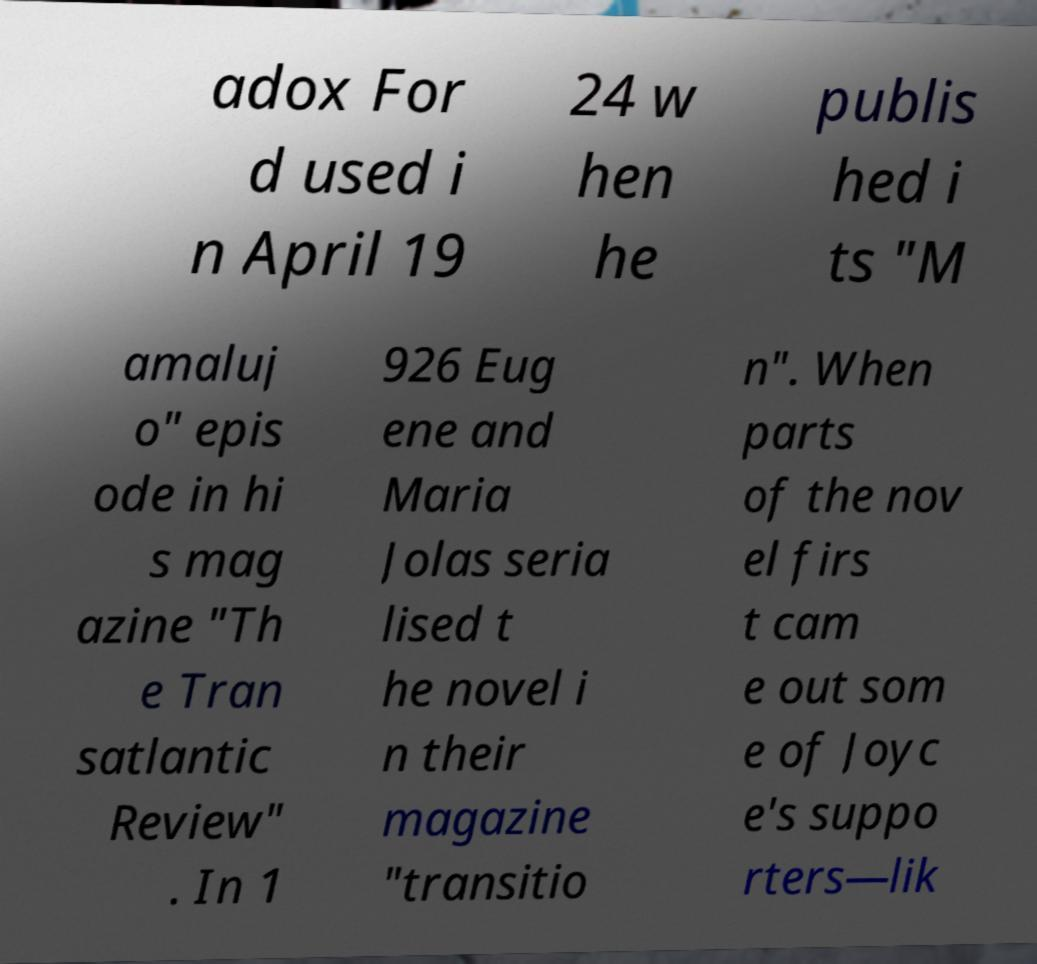There's text embedded in this image that I need extracted. Can you transcribe it verbatim? adox For d used i n April 19 24 w hen he publis hed i ts "M amaluj o" epis ode in hi s mag azine "Th e Tran satlantic Review" . In 1 926 Eug ene and Maria Jolas seria lised t he novel i n their magazine "transitio n". When parts of the nov el firs t cam e out som e of Joyc e's suppo rters—lik 